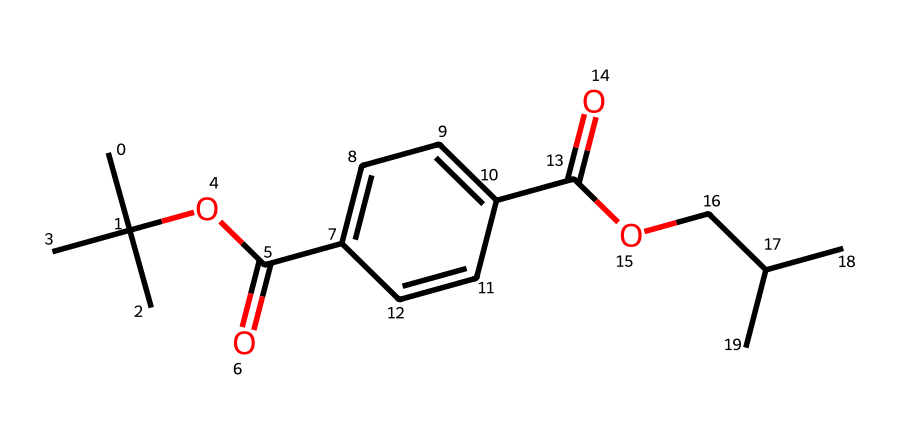What is the molecular formula of the compound represented by this SMILES? To determine the molecular formula, we need to count the types of atoms in the structure. The SMILES representation indicates carbon (C), oxygen (O), and hydrogen (H) atoms. Upon analyzing the structure, we find the counts: 19 carbon atoms, 34 hydrogen atoms, and 4 oxygen atoms. Thus, the molecular formula can be summarized as C19H34O4.
Answer: C19H34O4 What functional groups are present in this molecule? By examining the SMILES, we identify multiple parts: there are ester (COO) groups and carboxylic acid (COOH) groups present due to the definitions of each group based on their connectivity. The presence of these groups indicates that the structure features both ester and acid functionalities.
Answer: ester, carboxylic acid How many total bonds are present in the molecule? The molecule contains various types of bonds, including single and double bonds. After breaking down the connections in the structure based on the SMILES, we find 27 single bonds and 2 double bonds. Summing these, we reach the total bond count of 29.
Answer: 29 What type of polymer is represented by this chemical structure? Analyzing the structure and the presence of repeating units suggests that this compound is a polyester. The repeating units in its composition and the presence of ester linkage confirm that it's part of the polyester family of polymers.
Answer: polyester How does this compound behave in water? When considering the molecular structure, the presence of polar functional groups, particularly the carboxylic acid and ester moieties, indicates that this compound would interact with water. Therefore, it can be inferred that polyesters, especially PET, have moderate solubility in water but better solubility in organic solvents.
Answer: moderately soluble 